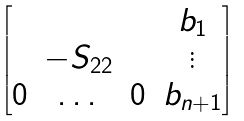Convert formula to latex. <formula><loc_0><loc_0><loc_500><loc_500>\begin{bmatrix} & & & b _ { 1 } \\ & - S _ { 2 2 } & & \vdots \\ 0 & \dots & 0 & b _ { n + 1 } \\ \end{bmatrix}</formula> 